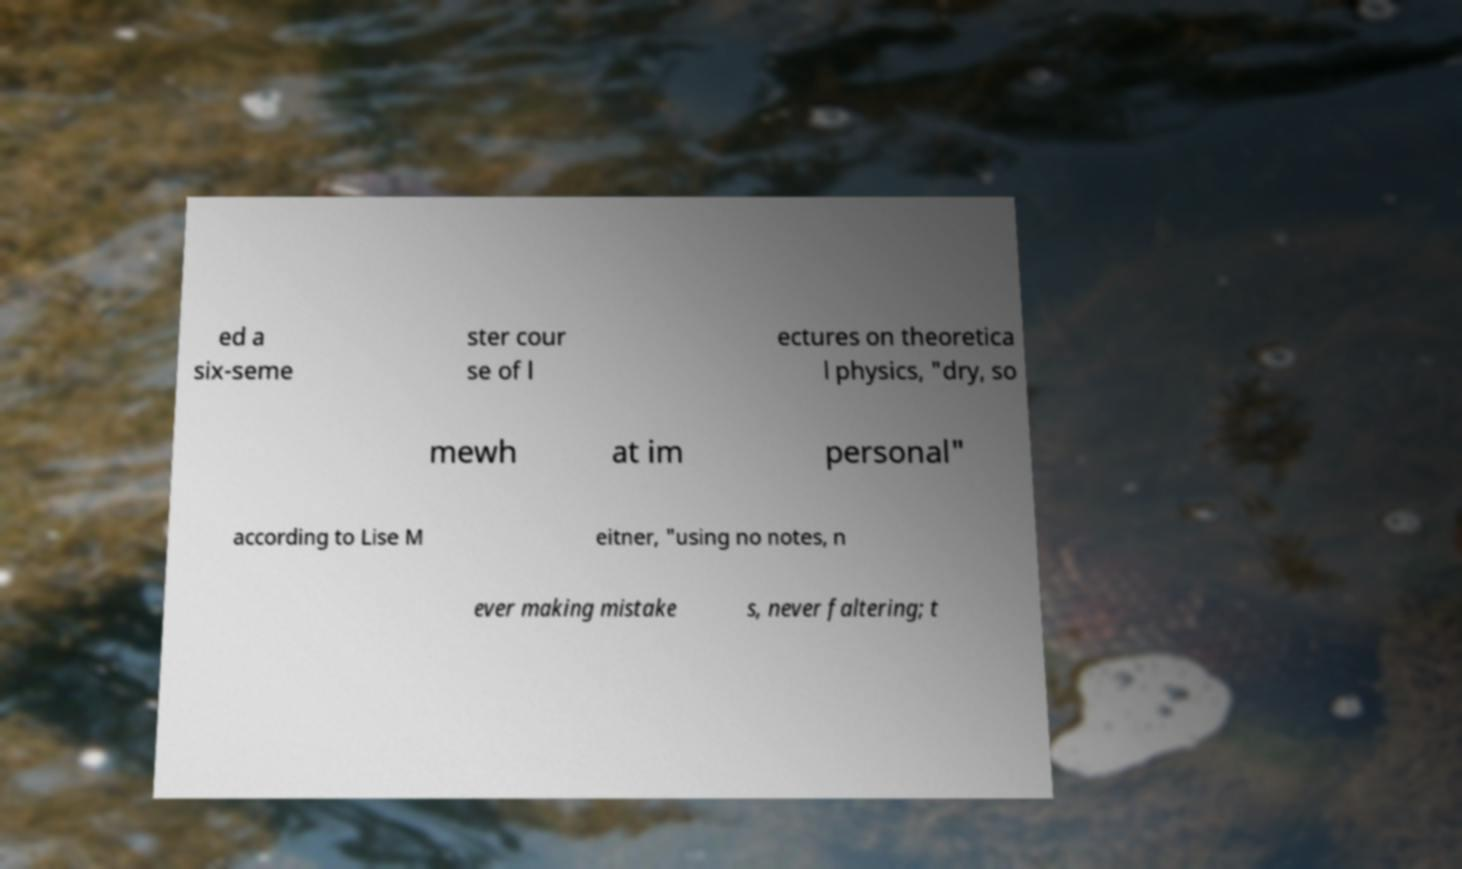Please identify and transcribe the text found in this image. ed a six-seme ster cour se of l ectures on theoretica l physics, "dry, so mewh at im personal" according to Lise M eitner, "using no notes, n ever making mistake s, never faltering; t 